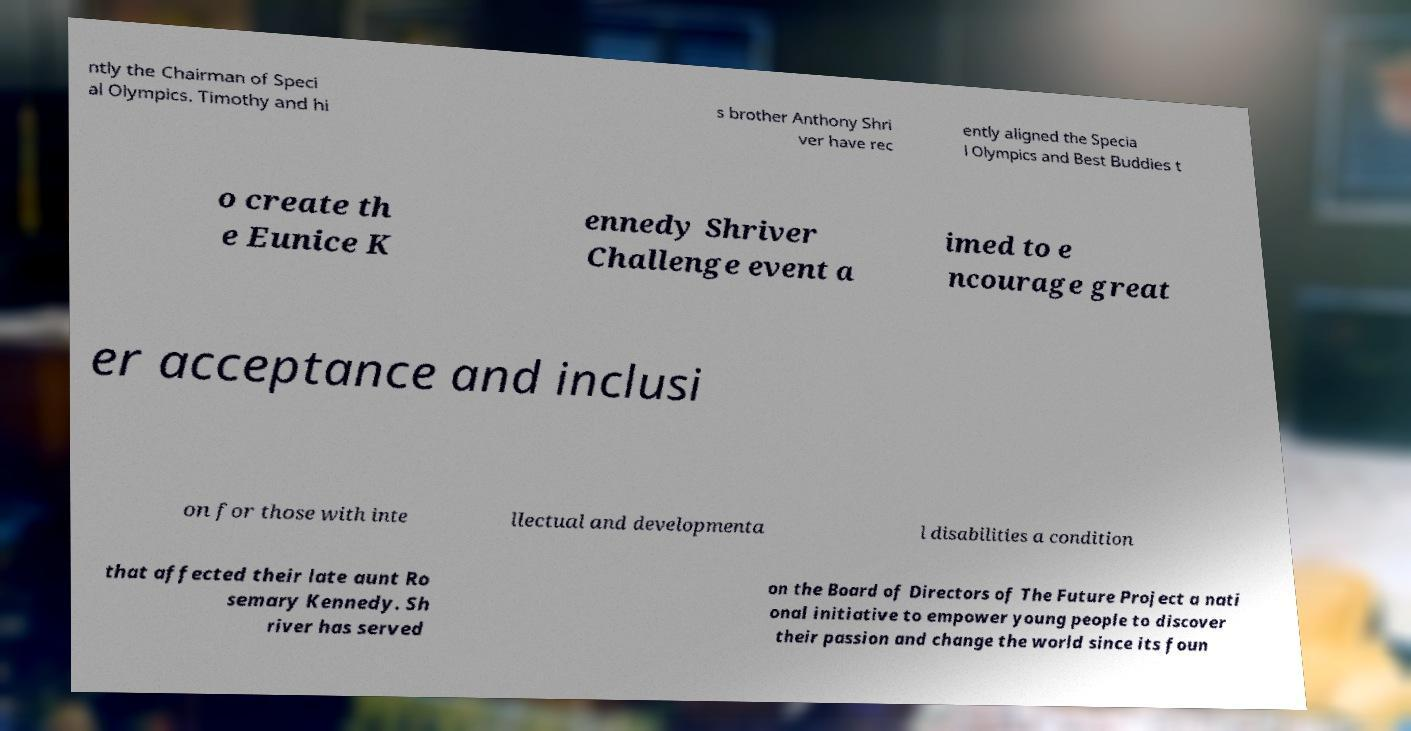Could you assist in decoding the text presented in this image and type it out clearly? ntly the Chairman of Speci al Olympics. Timothy and hi s brother Anthony Shri ver have rec ently aligned the Specia l Olympics and Best Buddies t o create th e Eunice K ennedy Shriver Challenge event a imed to e ncourage great er acceptance and inclusi on for those with inte llectual and developmenta l disabilities a condition that affected their late aunt Ro semary Kennedy. Sh river has served on the Board of Directors of The Future Project a nati onal initiative to empower young people to discover their passion and change the world since its foun 